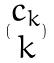<formula> <loc_0><loc_0><loc_500><loc_500>( \begin{matrix} c _ { k } \\ k \end{matrix} )</formula> 